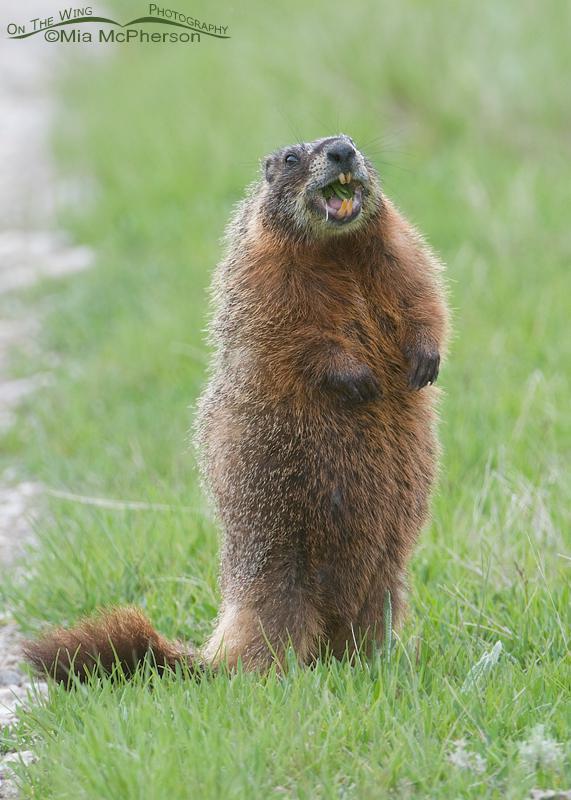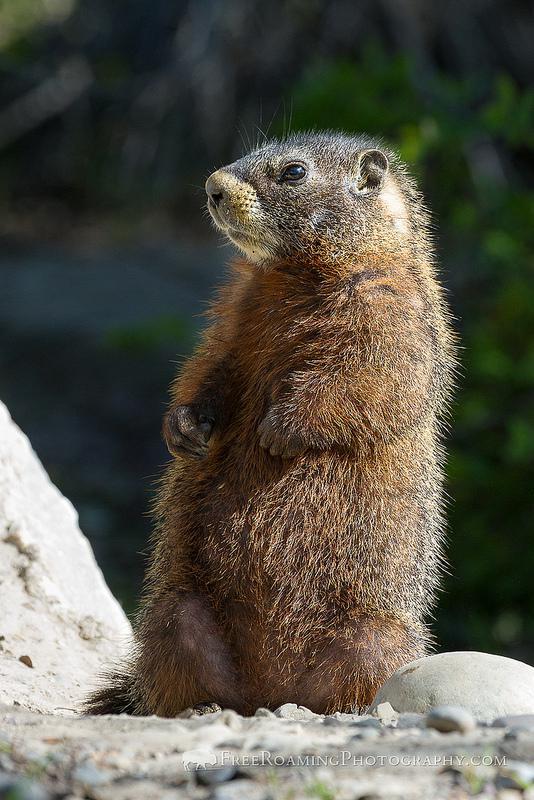The first image is the image on the left, the second image is the image on the right. Assess this claim about the two images: "Each image contains a single marmot, and the right image features a marmot standing and facing leftward.". Correct or not? Answer yes or no. Yes. 